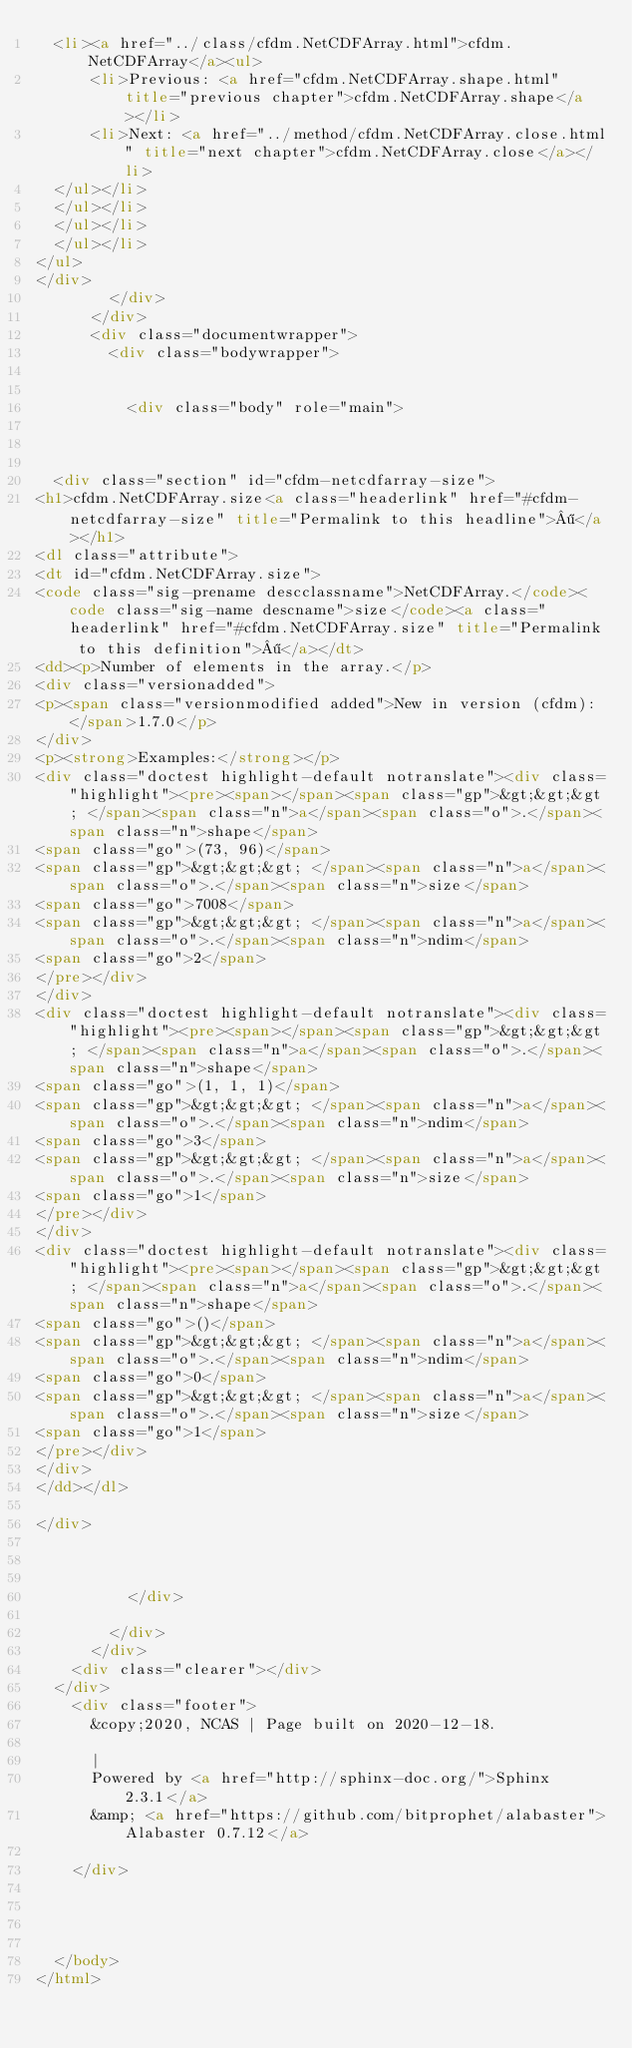Convert code to text. <code><loc_0><loc_0><loc_500><loc_500><_HTML_>  <li><a href="../class/cfdm.NetCDFArray.html">cfdm.NetCDFArray</a><ul>
      <li>Previous: <a href="cfdm.NetCDFArray.shape.html" title="previous chapter">cfdm.NetCDFArray.shape</a></li>
      <li>Next: <a href="../method/cfdm.NetCDFArray.close.html" title="next chapter">cfdm.NetCDFArray.close</a></li>
  </ul></li>
  </ul></li>
  </ul></li>
  </ul></li>
</ul>
</div>
        </div>
      </div>
      <div class="documentwrapper">
        <div class="bodywrapper">
          

          <div class="body" role="main">
            


  <div class="section" id="cfdm-netcdfarray-size">
<h1>cfdm.NetCDFArray.size<a class="headerlink" href="#cfdm-netcdfarray-size" title="Permalink to this headline">¶</a></h1>
<dl class="attribute">
<dt id="cfdm.NetCDFArray.size">
<code class="sig-prename descclassname">NetCDFArray.</code><code class="sig-name descname">size</code><a class="headerlink" href="#cfdm.NetCDFArray.size" title="Permalink to this definition">¶</a></dt>
<dd><p>Number of elements in the array.</p>
<div class="versionadded">
<p><span class="versionmodified added">New in version (cfdm): </span>1.7.0</p>
</div>
<p><strong>Examples:</strong></p>
<div class="doctest highlight-default notranslate"><div class="highlight"><pre><span></span><span class="gp">&gt;&gt;&gt; </span><span class="n">a</span><span class="o">.</span><span class="n">shape</span>
<span class="go">(73, 96)</span>
<span class="gp">&gt;&gt;&gt; </span><span class="n">a</span><span class="o">.</span><span class="n">size</span>
<span class="go">7008</span>
<span class="gp">&gt;&gt;&gt; </span><span class="n">a</span><span class="o">.</span><span class="n">ndim</span>
<span class="go">2</span>
</pre></div>
</div>
<div class="doctest highlight-default notranslate"><div class="highlight"><pre><span></span><span class="gp">&gt;&gt;&gt; </span><span class="n">a</span><span class="o">.</span><span class="n">shape</span>
<span class="go">(1, 1, 1)</span>
<span class="gp">&gt;&gt;&gt; </span><span class="n">a</span><span class="o">.</span><span class="n">ndim</span>
<span class="go">3</span>
<span class="gp">&gt;&gt;&gt; </span><span class="n">a</span><span class="o">.</span><span class="n">size</span>
<span class="go">1</span>
</pre></div>
</div>
<div class="doctest highlight-default notranslate"><div class="highlight"><pre><span></span><span class="gp">&gt;&gt;&gt; </span><span class="n">a</span><span class="o">.</span><span class="n">shape</span>
<span class="go">()</span>
<span class="gp">&gt;&gt;&gt; </span><span class="n">a</span><span class="o">.</span><span class="n">ndim</span>
<span class="go">0</span>
<span class="gp">&gt;&gt;&gt; </span><span class="n">a</span><span class="o">.</span><span class="n">size</span>
<span class="go">1</span>
</pre></div>
</div>
</dd></dl>

</div>



          </div>
          
        </div>
      </div>
    <div class="clearer"></div>
  </div>
    <div class="footer">
      &copy;2020, NCAS | Page built on 2020-12-18.
      
      |
      Powered by <a href="http://sphinx-doc.org/">Sphinx 2.3.1</a>
      &amp; <a href="https://github.com/bitprophet/alabaster">Alabaster 0.7.12</a>
      
    </div>

    

    
  </body>
</html></code> 